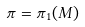<formula> <loc_0><loc_0><loc_500><loc_500>\pi = \pi _ { 1 } ( M )</formula> 